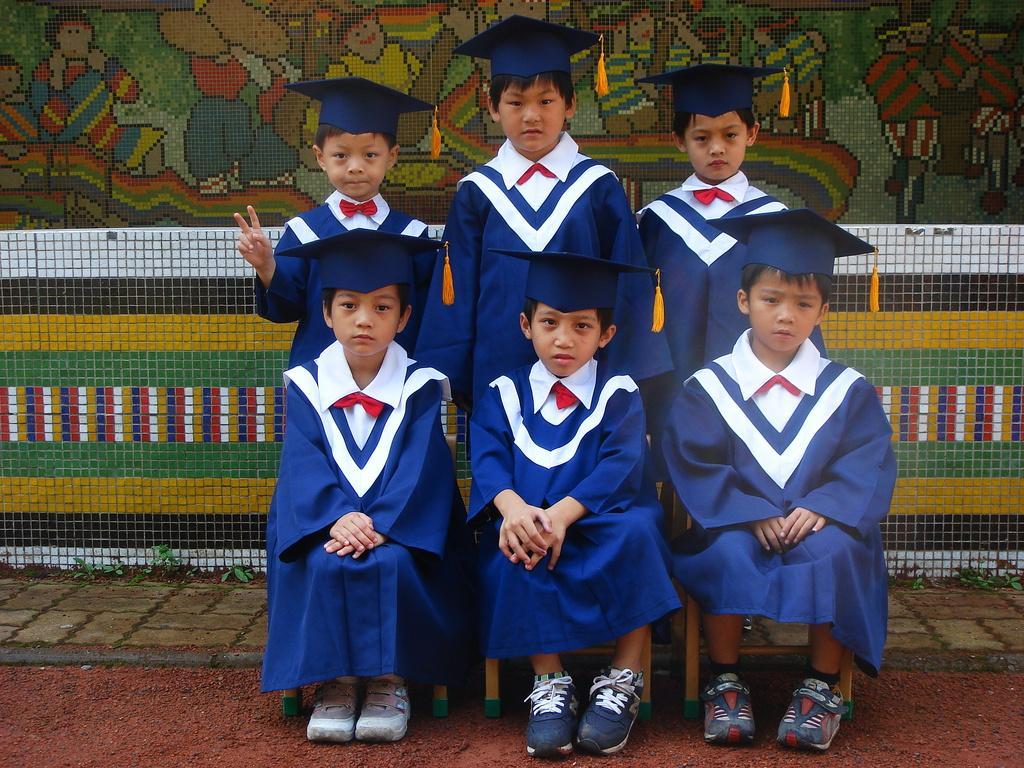How would you summarize this image in a sentence or two? In this picture we can see kids, few are sitting on the chairs and few are standing, behind them we can see fence and painting on the wall. 